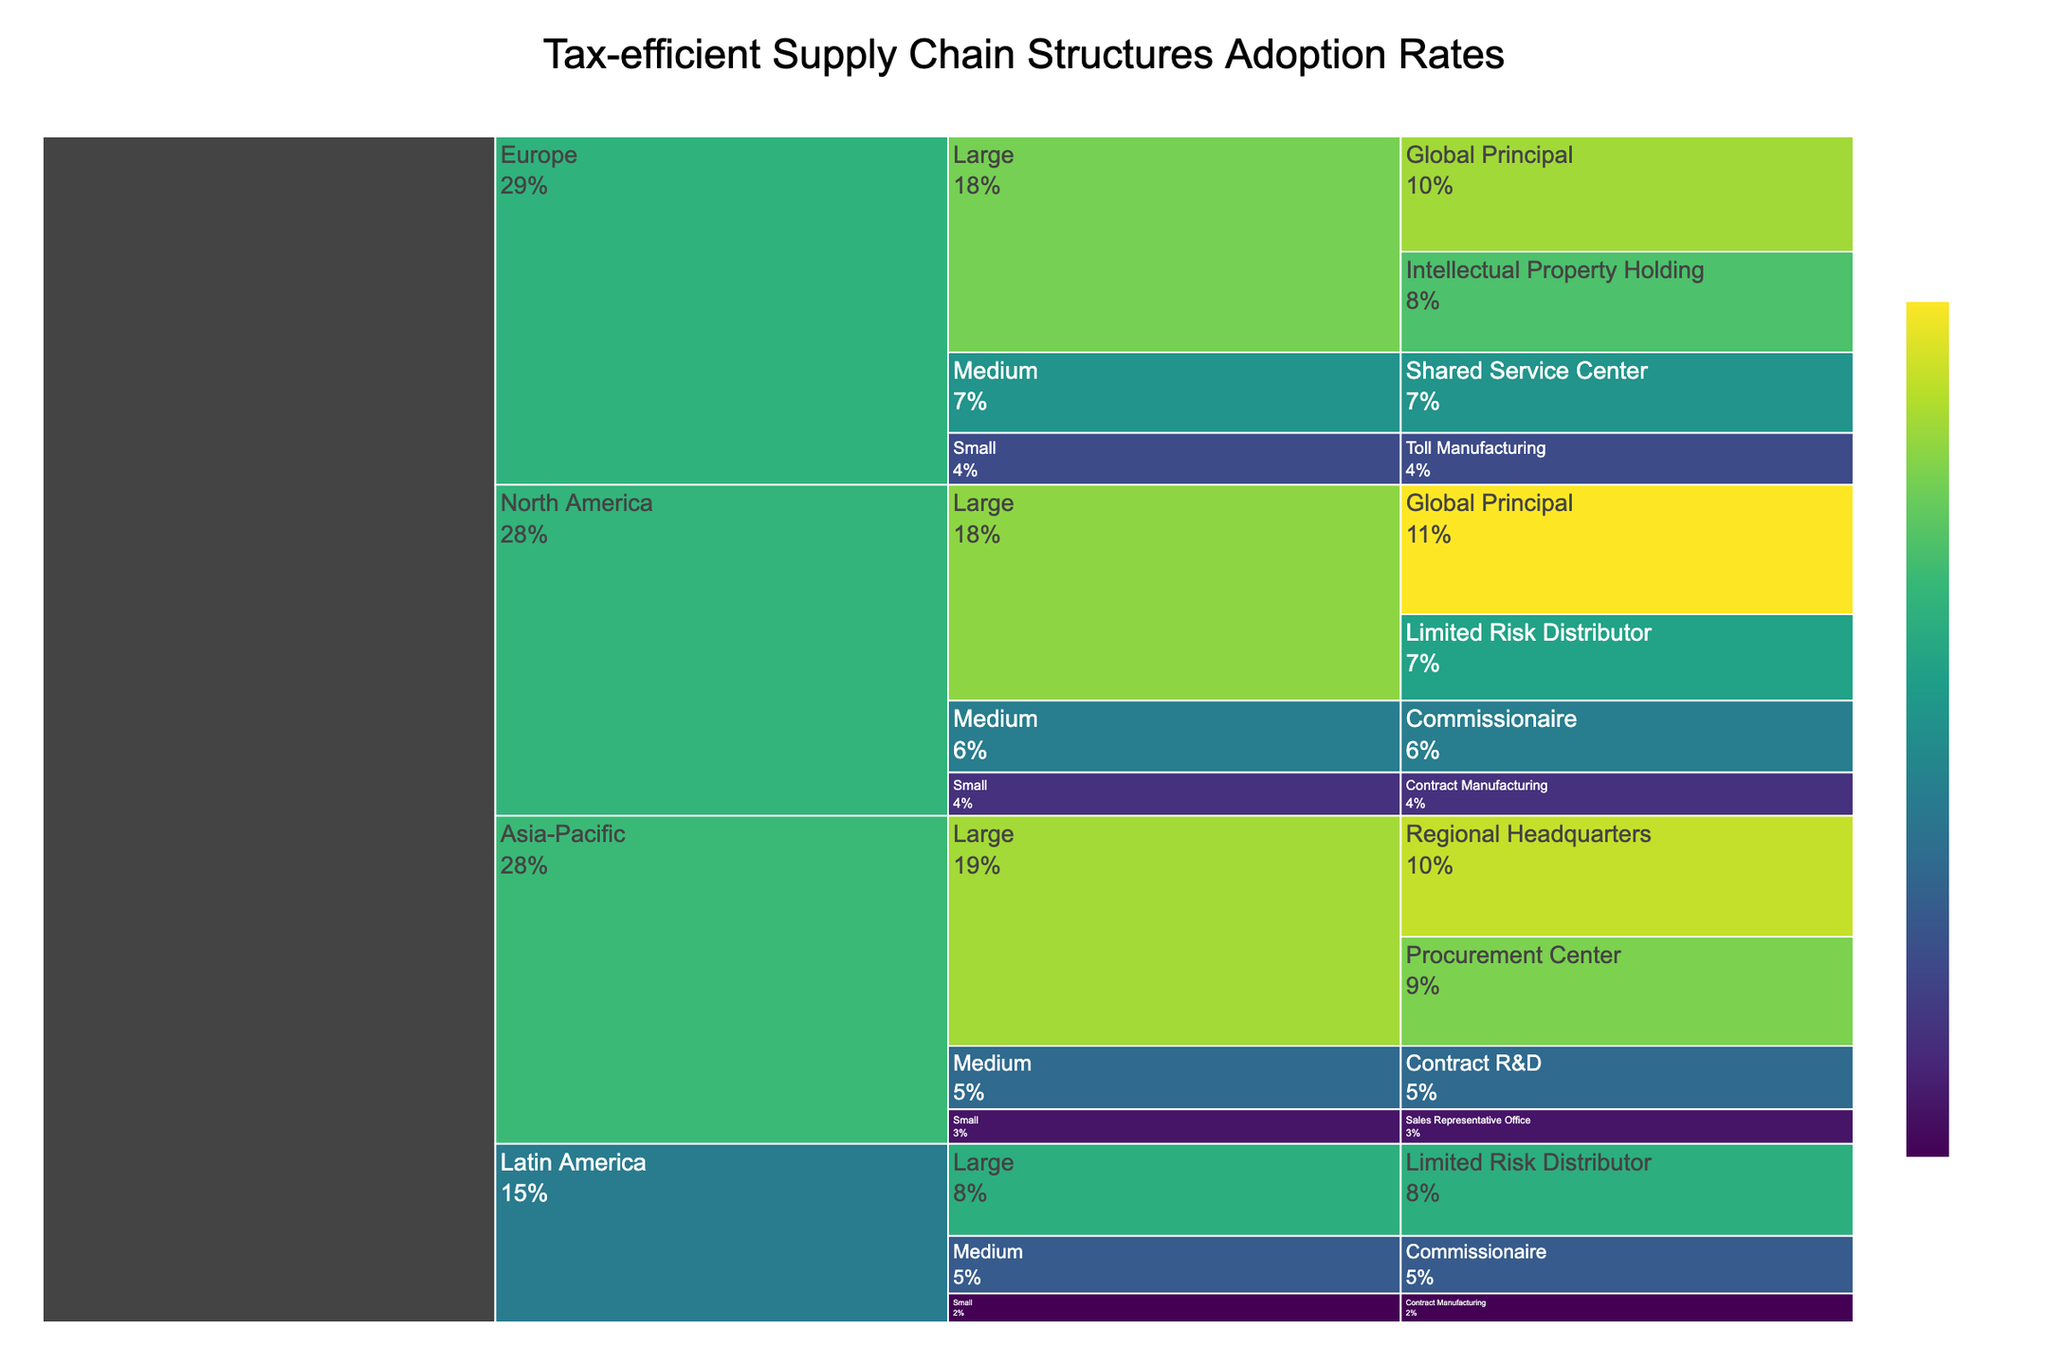What region has the highest adoption rate for a specific structure among large companies? Identify the regions under the large companies' categories and compare their adoption rates for their unique structures. For example, North America's Global Principal structure has a 45% adoption rate, which is the highest.
Answer: North America Which structure has the lowest adoption rate for medium-sized companies in Asia-Pacific? Look for the structure under the Asia-Pacific region and medium-sized companies and compare their adoption rates. The Contract R&D has an adoption rate of 22%.
Answer: Contract R&D What is the total adoption rate for all structures in Europe for small companies? Sum the adoption rates for all structures under Europe for small companies. That is 18% for Toll Manufacturing. Thus, the total is 18%.
Answer: 18% Which structure has a higher adoption rate in North America: Commissionaire for medium companies or Limited Risk Distributor for large companies? Compare the adoption rates for Commissionaire (25%) for medium companies to Limited Risk Distributor (30%) for large companies in North America. Limited Risk Distributor has a higher rate.
Answer: Limited Risk Distributor In which region do small companies have the lowest adoption rate, and what is it? Compare the adoption rates for all structures for small companies in different regions. Latin America's Contract Manufacturing with 10% has the lowest rate.
Answer: Latin America, 10% Which structure has the highest adoption rate among all regions and company sizes? Compare all the adoption rates across different regions and company sizes. North America's Global Principal for large companies at 45% has the highest adoption rate.
Answer: Global Principal How does the adoption rate for Intellectual Property Holding in large European companies compare to Procurement Center in large Asia-Pacific companies? Compare the adoption rates: Intellectual Property Holding has 35% in Europe; Procurement Center has 38% in Asia-Pacific. Procurement Center has a higher rate.
Answer: Procurement Center What is the average adoption rate of all structures adopted by large companies in Latin America? Sum the adoption rates of all structures for large companies in Latin America and divide by the number of structures. Limited Risk Distributor is the only structure with a 32%. So the average is 32%.
Answer: 32% Which region has the most diverse types of tax-efficient supply chain structures adopted for medium-sized companies? Compare the number of unique structures under the medium-sized companies for each region. Europe has structures like Shared Service Center and Commissionaire making it more diverse compared to other regions.
Answer: Europe 